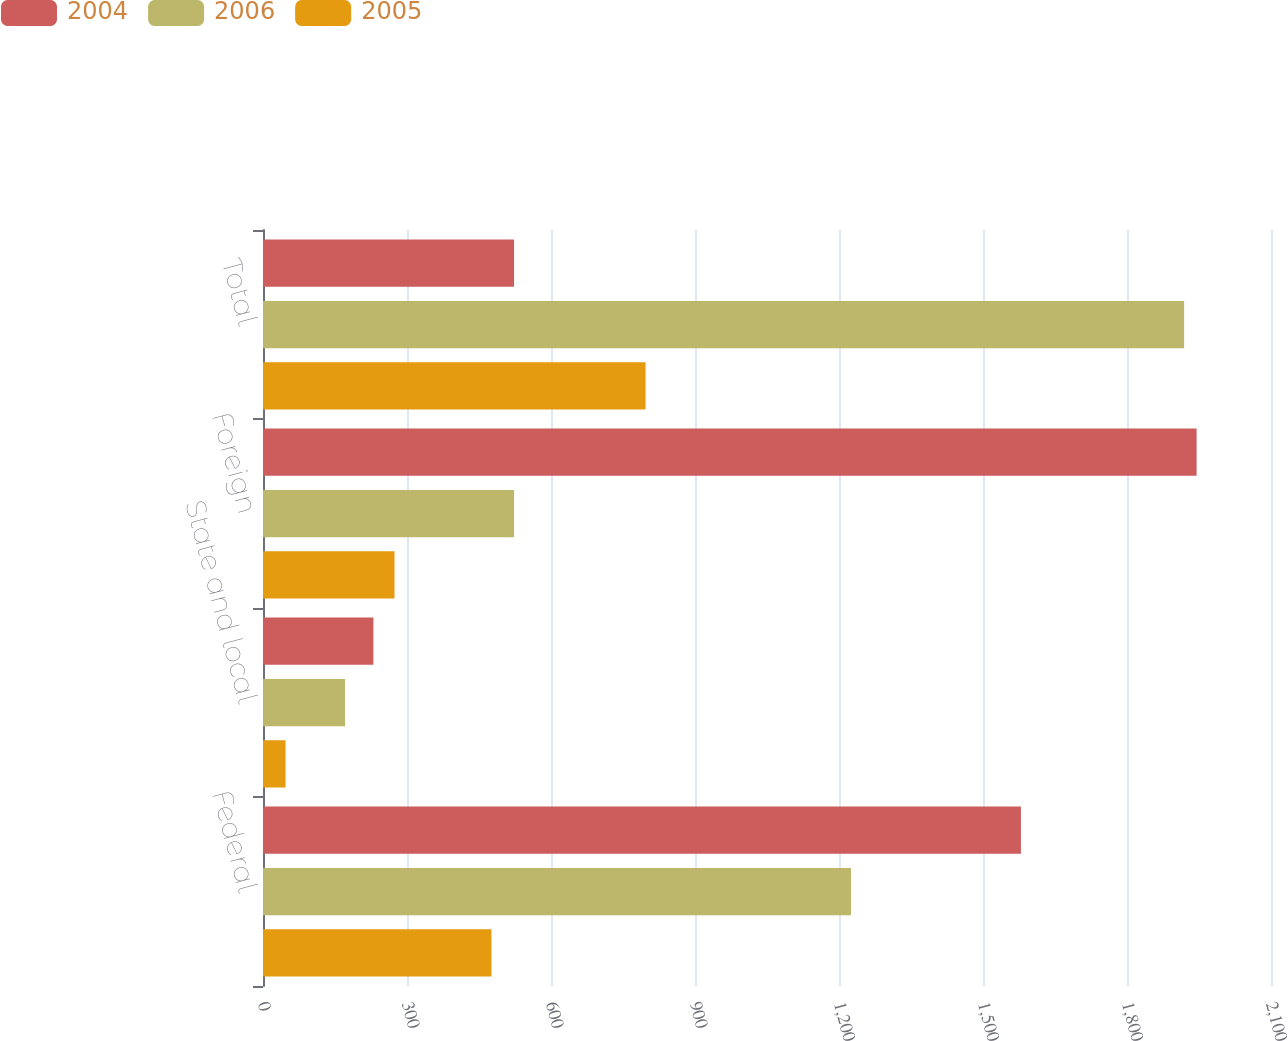Convert chart. <chart><loc_0><loc_0><loc_500><loc_500><stacked_bar_chart><ecel><fcel>Federal<fcel>State and local<fcel>Foreign<fcel>Total<nl><fcel>2004<fcel>1579<fcel>230<fcel>1945<fcel>523<nl><fcel>2006<fcel>1225<fcel>171<fcel>523<fcel>1919<nl><fcel>2005<fcel>476<fcel>47<fcel>274<fcel>797<nl></chart> 